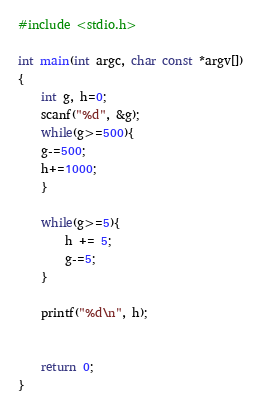Convert code to text. <code><loc_0><loc_0><loc_500><loc_500><_C_>#include <stdio.h>

int main(int argc, char const *argv[])
{
	int g, h=0;
	scanf("%d", &g);
	while(g>=500){
	g-=500;
	h+=1000;
	}

	while(g>=5){
		h += 5;
		g-=5;
	}

	printf("%d\n", h);


	return 0;
}
</code> 